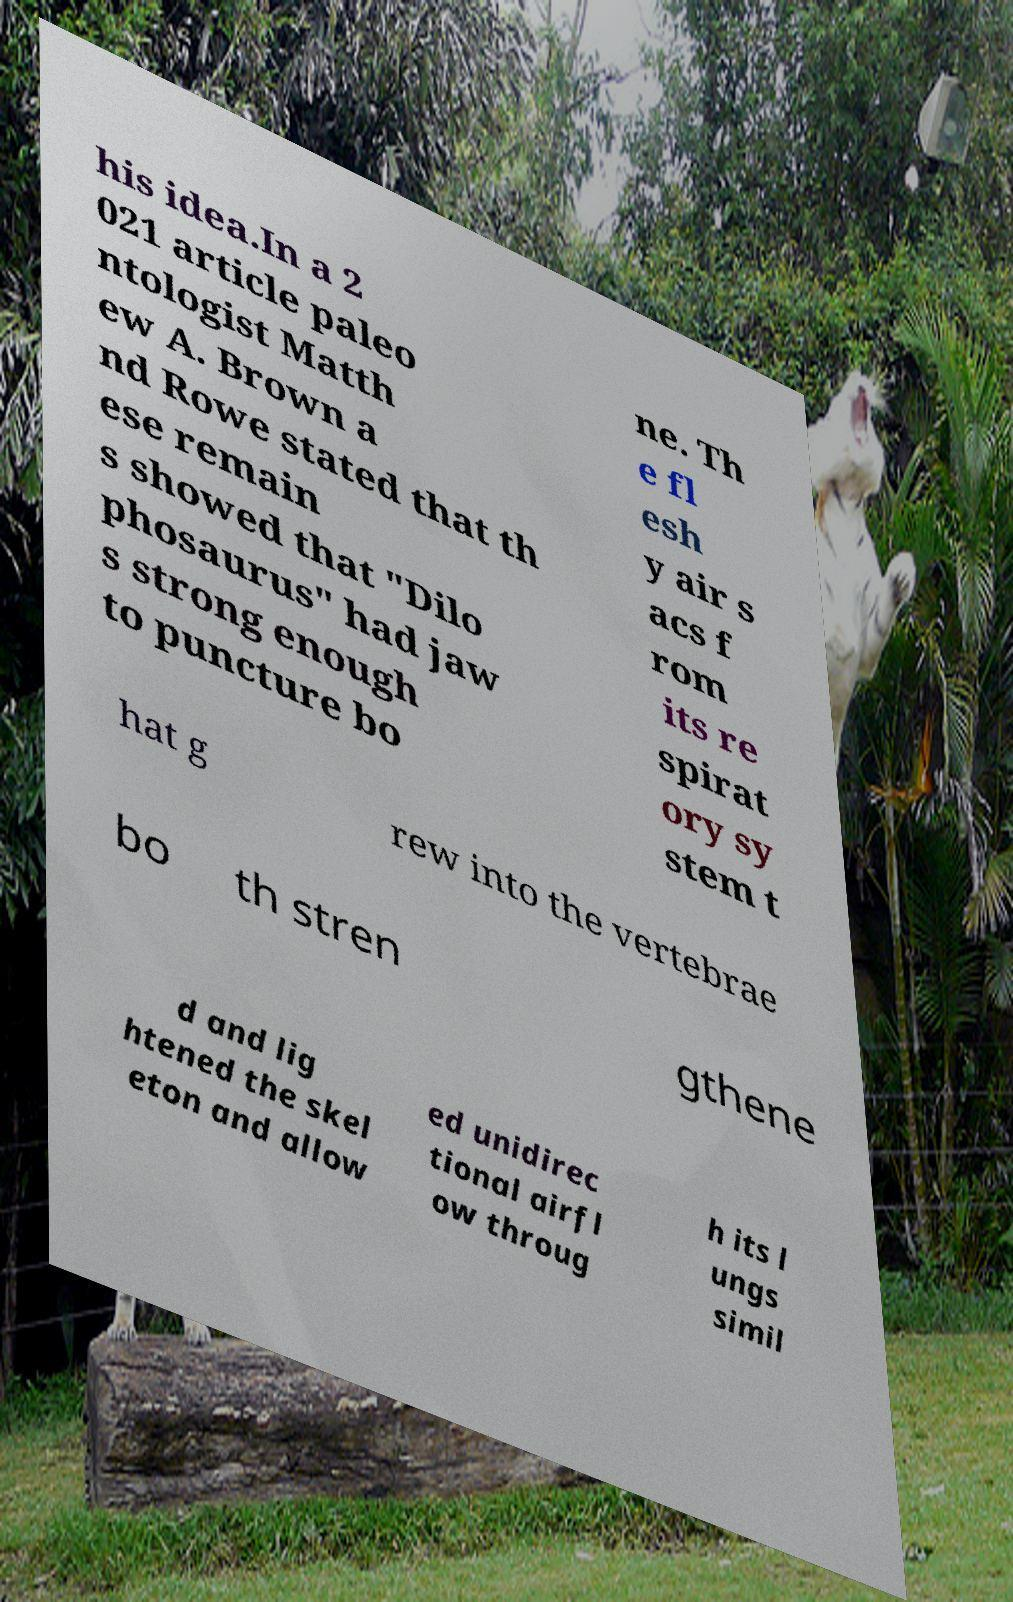I need the written content from this picture converted into text. Can you do that? his idea.In a 2 021 article paleo ntologist Matth ew A. Brown a nd Rowe stated that th ese remain s showed that "Dilo phosaurus" had jaw s strong enough to puncture bo ne. Th e fl esh y air s acs f rom its re spirat ory sy stem t hat g rew into the vertebrae bo th stren gthene d and lig htened the skel eton and allow ed unidirec tional airfl ow throug h its l ungs simil 